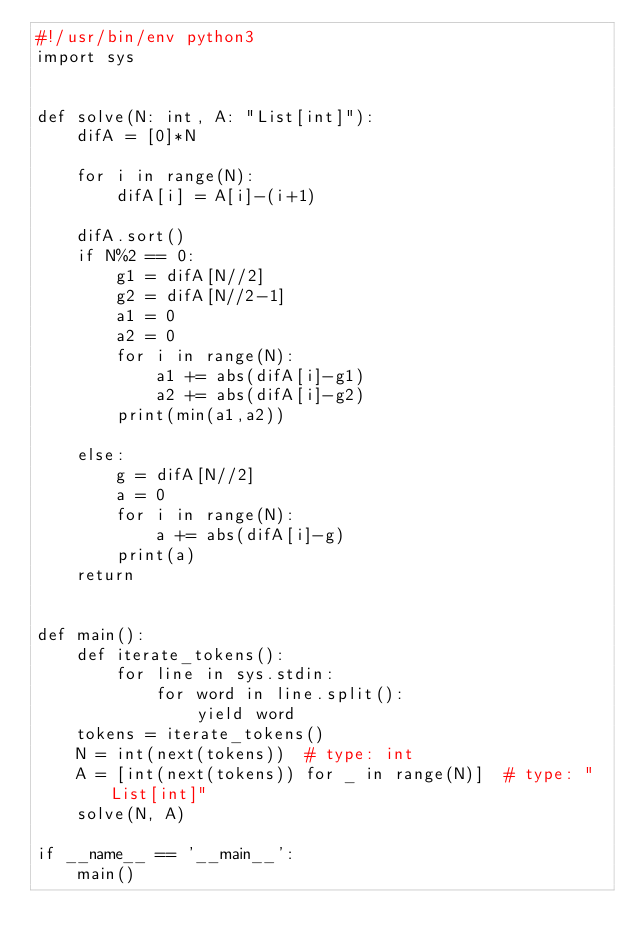Convert code to text. <code><loc_0><loc_0><loc_500><loc_500><_Python_>#!/usr/bin/env python3
import sys


def solve(N: int, A: "List[int]"):
    difA = [0]*N

    for i in range(N):
        difA[i] = A[i]-(i+1)

    difA.sort()
    if N%2 == 0:
        g1 = difA[N//2]
        g2 = difA[N//2-1]
        a1 = 0
        a2 = 0
        for i in range(N):
            a1 += abs(difA[i]-g1)
            a2 += abs(difA[i]-g2)
        print(min(a1,a2))
            
    else:
        g = difA[N//2]
        a = 0
        for i in range(N):
            a += abs(difA[i]-g)
        print(a)
    return


def main():
    def iterate_tokens():
        for line in sys.stdin:
            for word in line.split():
                yield word
    tokens = iterate_tokens()
    N = int(next(tokens))  # type: int
    A = [int(next(tokens)) for _ in range(N)]  # type: "List[int]"
    solve(N, A)

if __name__ == '__main__':
    main()
</code> 